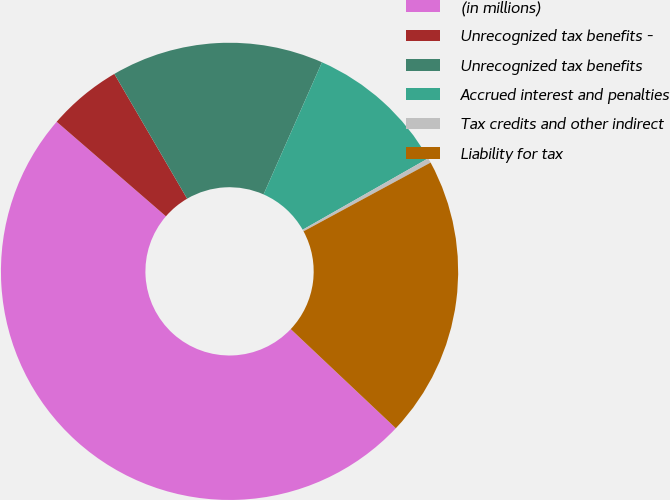<chart> <loc_0><loc_0><loc_500><loc_500><pie_chart><fcel>(in millions)<fcel>Unrecognized tax benefits -<fcel>Unrecognized tax benefits<fcel>Accrued interest and penalties<fcel>Tax credits and other indirect<fcel>Liability for tax<nl><fcel>49.31%<fcel>5.24%<fcel>15.03%<fcel>10.14%<fcel>0.34%<fcel>19.93%<nl></chart> 